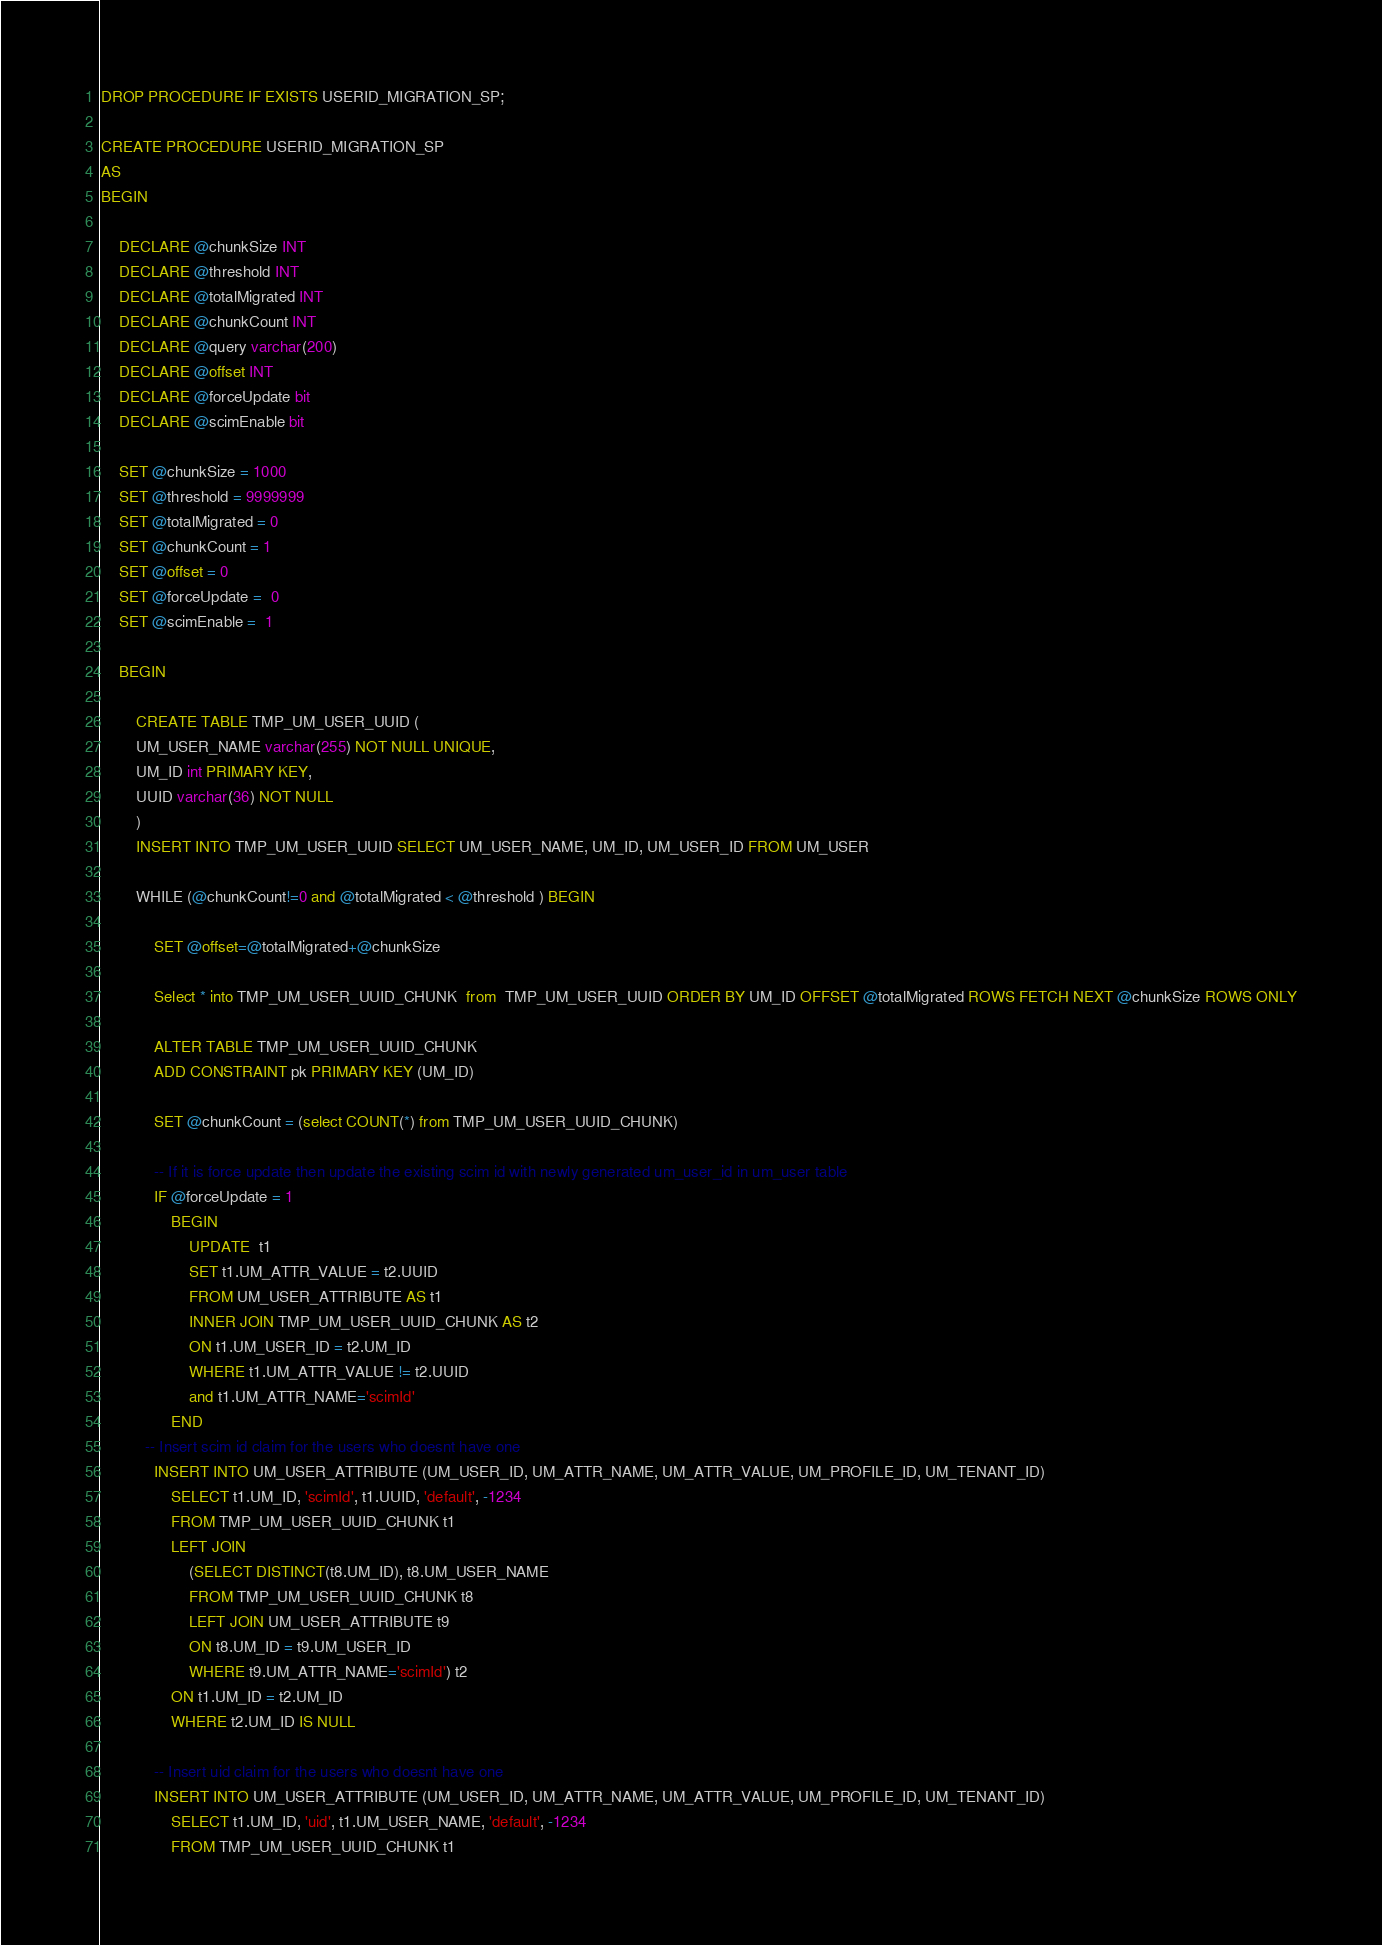<code> <loc_0><loc_0><loc_500><loc_500><_SQL_>DROP PROCEDURE IF EXISTS USERID_MIGRATION_SP;

CREATE PROCEDURE USERID_MIGRATION_SP
AS
BEGIN
 
    DECLARE @chunkSize INT
    DECLARE @threshold INT
    DECLARE @totalMigrated INT
    DECLARE @chunkCount INT
    DECLARE @query varchar(200)
    DECLARE @offset INT
    DECLARE @forceUpdate bit
    DECLARE @scimEnable bit 
   
    SET @chunkSize = 1000
    SET @threshold = 9999999
    SET @totalMigrated = 0
    SET @chunkCount = 1
    SET @offset = 0
    SET @forceUpdate =  0
    SET @scimEnable =  1
    
	BEGIN
		
		CREATE TABLE TMP_UM_USER_UUID (
        UM_USER_NAME varchar(255) NOT NULL UNIQUE,
        UM_ID int PRIMARY KEY,
        UUID varchar(36) NOT NULL
        )
        INSERT INTO TMP_UM_USER_UUID SELECT UM_USER_NAME, UM_ID, UM_USER_ID FROM UM_USER
        
        WHILE (@chunkCount!=0 and @totalMigrated < @threshold ) BEGIN
            
            SET @offset=@totalMigrated+@chunkSize    
            
            Select * into TMP_UM_USER_UUID_CHUNK  from  TMP_UM_USER_UUID ORDER BY UM_ID OFFSET @totalMigrated ROWS FETCH NEXT @chunkSize ROWS ONLY
            
            ALTER TABLE TMP_UM_USER_UUID_CHUNK
            ADD CONSTRAINT pk PRIMARY KEY (UM_ID)
       	    
		    SET @chunkCount = (select COUNT(*) from TMP_UM_USER_UUID_CHUNK)
		    
            -- If it is force update then update the existing scim id with newly generated um_user_id in um_user table
            IF @forceUpdate = 1
                BEGIN
                    UPDATE  t1 
                    SET t1.UM_ATTR_VALUE = t2.UUID
                    FROM UM_USER_ATTRIBUTE AS t1
                    INNER JOIN TMP_UM_USER_UUID_CHUNK AS t2 
                    ON t1.UM_USER_ID = t2.UM_ID
                    WHERE t1.UM_ATTR_VALUE != t2.UUID
                    and t1.UM_ATTR_NAME='scimId'
                END 
		  -- Insert scim id claim for the users who doesnt have one
			INSERT INTO UM_USER_ATTRIBUTE (UM_USER_ID, UM_ATTR_NAME, UM_ATTR_VALUE, UM_PROFILE_ID, UM_TENANT_ID)
                SELECT t1.UM_ID, 'scimId', t1.UUID, 'default', -1234
                FROM TMP_UM_USER_UUID_CHUNK t1
                LEFT JOIN 
                    (SELECT DISTINCT(t8.UM_ID), t8.UM_USER_NAME
                    FROM TMP_UM_USER_UUID_CHUNK t8
                    LEFT JOIN UM_USER_ATTRIBUTE t9
                    ON t8.UM_ID = t9.UM_USER_ID
                    WHERE t9.UM_ATTR_NAME='scimId') t2
                ON t1.UM_ID = t2.UM_ID
                WHERE t2.UM_ID IS NULL
            
            -- Insert uid claim for the users who doesnt have one
            INSERT INTO UM_USER_ATTRIBUTE (UM_USER_ID, UM_ATTR_NAME, UM_ATTR_VALUE, UM_PROFILE_ID, UM_TENANT_ID)
                SELECT t1.UM_ID, 'uid', t1.UM_USER_NAME, 'default', -1234
                FROM TMP_UM_USER_UUID_CHUNK t1</code> 